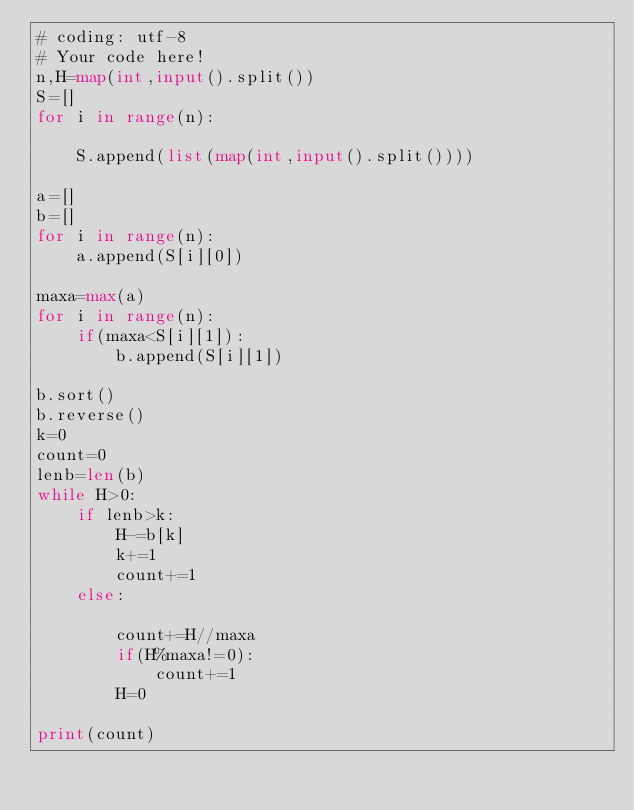Convert code to text. <code><loc_0><loc_0><loc_500><loc_500><_Python_># coding: utf-8
# Your code here!
n,H=map(int,input().split())
S=[]
for i in range(n):
    
    S.append(list(map(int,input().split())))
    
a=[]
b=[]
for i in range(n):
    a.append(S[i][0])

maxa=max(a)    
for i in range(n):
    if(maxa<S[i][1]):
        b.append(S[i][1])

b.sort()
b.reverse()
k=0
count=0
lenb=len(b)
while H>0:
    if lenb>k:
        H-=b[k]
        k+=1
        count+=1
    else:
        
        count+=H//maxa
        if(H%maxa!=0):
            count+=1
        H=0

print(count)
</code> 